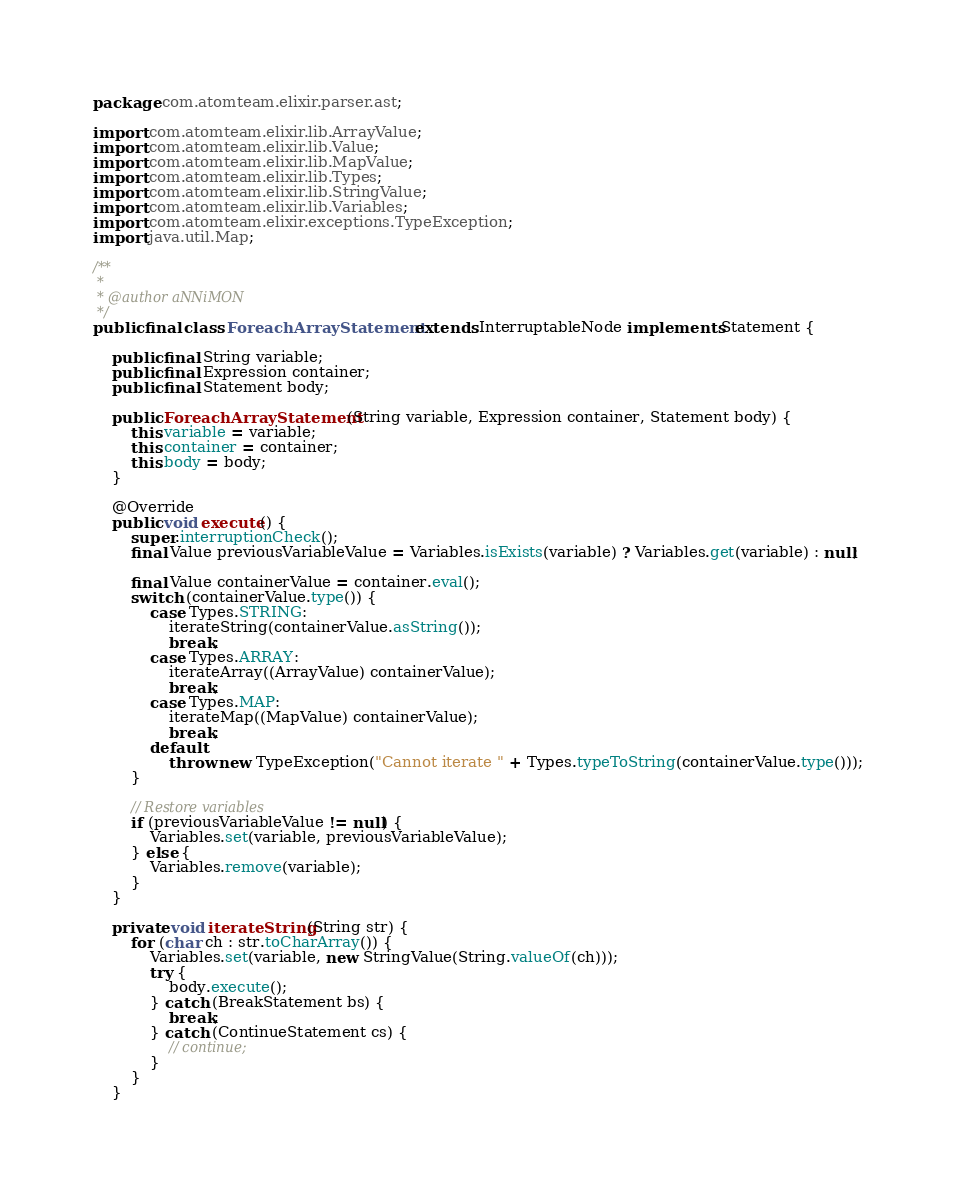Convert code to text. <code><loc_0><loc_0><loc_500><loc_500><_Java_>package com.atomteam.elixir.parser.ast;

import com.atomteam.elixir.lib.ArrayValue;
import com.atomteam.elixir.lib.Value;
import com.atomteam.elixir.lib.MapValue;
import com.atomteam.elixir.lib.Types;
import com.atomteam.elixir.lib.StringValue;
import com.atomteam.elixir.lib.Variables;
import com.atomteam.elixir.exceptions.TypeException;
import java.util.Map;

/**
 *
 * @author aNNiMON
 */
public final class ForeachArrayStatement extends InterruptableNode implements Statement {
    
    public final String variable;
    public final Expression container;
    public final Statement body;

    public ForeachArrayStatement(String variable, Expression container, Statement body) {
        this.variable = variable;
        this.container = container;
        this.body = body;
    }

    @Override
    public void execute() {
        super.interruptionCheck();
        final Value previousVariableValue = Variables.isExists(variable) ? Variables.get(variable) : null;

        final Value containerValue = container.eval();
        switch (containerValue.type()) {
            case Types.STRING:
                iterateString(containerValue.asString());
                break;
            case Types.ARRAY:
                iterateArray((ArrayValue) containerValue);
                break;
            case Types.MAP:
                iterateMap((MapValue) containerValue);
                break;
            default:
                throw new TypeException("Cannot iterate " + Types.typeToString(containerValue.type()));
        }

        // Restore variables
        if (previousVariableValue != null) {
            Variables.set(variable, previousVariableValue);
        } else {
            Variables.remove(variable);
        }
    }

    private void iterateString(String str) {
        for (char ch : str.toCharArray()) {
            Variables.set(variable, new StringValue(String.valueOf(ch)));
            try {
                body.execute();
            } catch (BreakStatement bs) {
                break;
            } catch (ContinueStatement cs) {
                // continue;
            }
        }
    }
</code> 